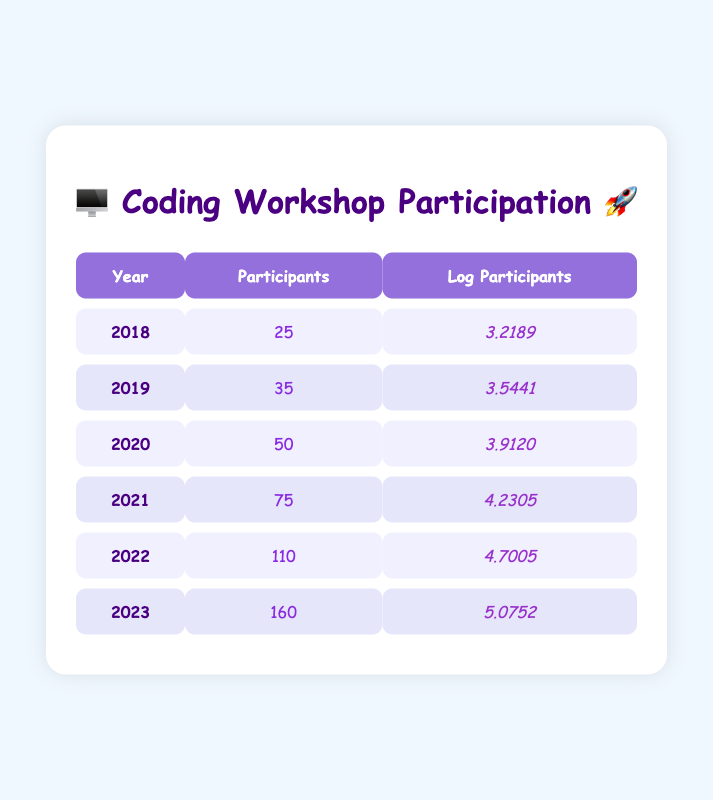What year had the most participants in the coding workshop? Looking at the "Participants" column, I see that the highest number of participants is 160, which occurred in the year 2023.
Answer: 2023 What was the number of participants in 2020? The table shows the participant number for the year 2020 as 50.
Answer: 50 What is the difference in the number of participants between 2018 and 2022? The number of participants in 2018 is 25 and in 2022 is 110. The difference is calculated as 110 - 25 = 85.
Answer: 85 What is the average number of participants from 2018 to 2023? To find the average, I sum the participants: 25 + 35 + 50 + 75 + 110 + 160 = 455. There are 6 years, so the average is 455 / 6 = 75.83.
Answer: 75.83 Is it true that the number of participants increased every year? Observing the participant numbers from each year in the table, I see 25, 35, 50, 75, 110, and 160. Each number is greater than the previous one, confirming it is true.
Answer: Yes What was the logarithmic value for the participants in 2021? The log participants value for the year 2021 is listed in the table as 4.2305.
Answer: 4.2305 How many participants were there in 2019 compared to 2021? The table shows 35 participants in 2019 and 75 in 2021. The comparison reveals that 2021 had 75 - 35 = 40 more participants than 2019.
Answer: 40 Which year shows the smallest increase in participants from the previous year? By evaluating the difference in participants: 2018 to 2019 = 10, 2019 to 2020 = 15, 2020 to 2021 = 25, 2021 to 2022 = 35, 2022 to 2023 = 50. The smallest increase is 10 from 2018 to 2019.
Answer: 2018 to 2019 What is the logarithmic value of participants in the year with the least participation, 2018? The table lists the log participants for 2018 as 3.2189.
Answer: 3.2189 